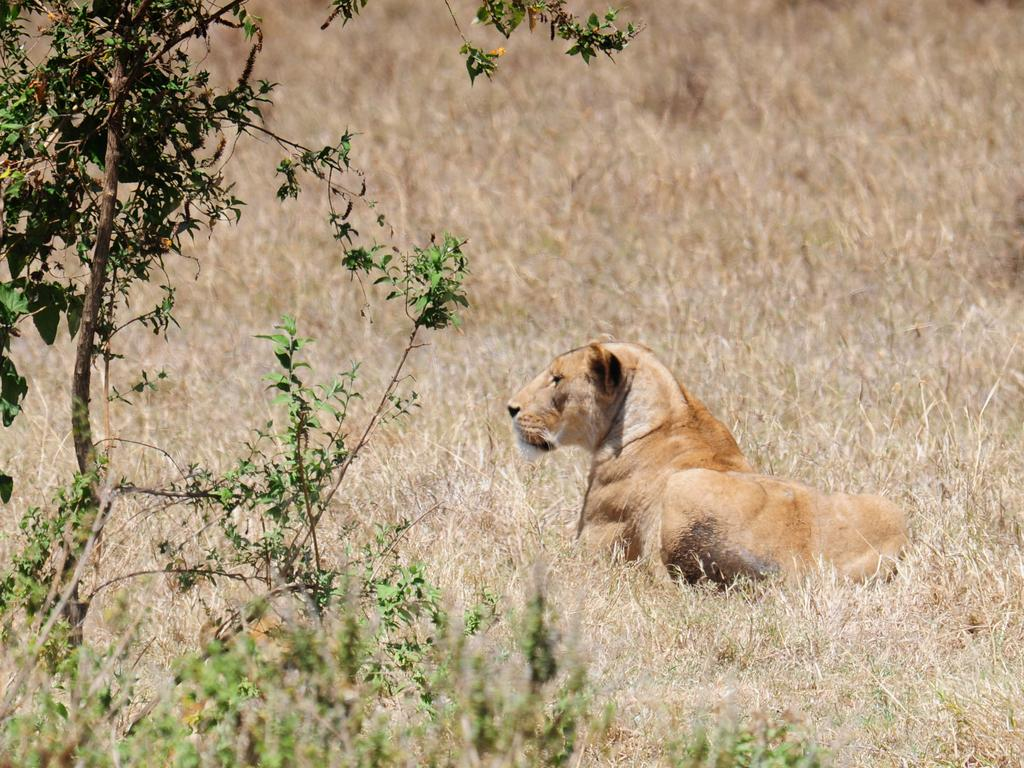What is the main subject in the middle of the picture? There is a lion in the middle of the picture. What can be seen on the left side of the picture? There are trees on the left side of the picture. What type of vegetation is visible in the background of the picture? Dry grass is visible in the background of the picture. Where might this picture have been taken? The picture might have been taken in a forest or a zoo. What historical event is the lion commemorating in the picture? The lion is not commemorating any historical event in the picture; it is simply a lion in its natural or zoo habitat. 